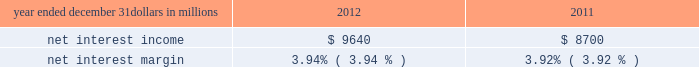Consolidated income statement review our consolidated income statement is presented in item 8 of this report .
Net income for 2012 was $ 3.0 billion compared with $ 3.1 billion for 2011 .
Revenue growth of 8 percent and a decline in the provision for credit losses were more than offset by a 16 percent increase in noninterest expense in 2012 compared to 2011 .
Further detail is included in the net interest income , noninterest income , provision for credit losses and noninterest expense portions of this consolidated income statement review .
Net interest income table 2 : net interest income and net interest margin year ended december 31 dollars in millions 2012 2011 .
Changes in net interest income and margin result from the interaction of the volume and composition of interest-earning assets and related yields , interest-bearing liabilities and related rates paid , and noninterest-bearing sources of funding .
See the statistical information ( unaudited ) 2013 average consolidated balance sheet and net interest analysis and analysis of year-to-year changes in net interest income in item 8 of this report and the discussion of purchase accounting accretion of purchased impaired loans in the consolidated balance sheet review in this item 7 for additional information .
The increase in net interest income in 2012 compared with 2011 was primarily due to the impact of the rbc bank ( usa ) acquisition , organic loan growth and lower funding costs .
Purchase accounting accretion remained stable at $ 1.1 billion in both periods .
The net interest margin was 3.94% ( 3.94 % ) for 2012 and 3.92% ( 3.92 % ) for 2011 .
The increase in the comparison was primarily due to a decrease in the weighted-average rate accrued on total interest- bearing liabilities of 29 basis points , largely offset by a 21 basis point decrease on the yield on total interest-earning assets .
The decrease in the rate on interest-bearing liabilities was primarily due to the runoff of maturing retail certificates of deposit and the redemption of additional trust preferred and hybrid capital securities during 2012 , in addition to an increase in fhlb borrowings and commercial paper as lower-cost funding sources .
The decrease in the yield on interest-earning assets was primarily due to lower rates on new loan volume and lower yields on new securities in the current low rate environment .
With respect to the first quarter of 2013 , we expect net interest income to decline by two to three percent compared to fourth quarter 2012 net interest income of $ 2.4 billion , due to a decrease in purchase accounting accretion of up to $ 50 to $ 60 million , including lower expected cash recoveries .
For the full year 2013 , we expect net interest income to decrease compared with 2012 , assuming an expected decline in purchase accounting accretion of approximately $ 400 million , while core net interest income is expected to increase in the year-over-year comparison .
We believe our net interest margin will come under pressure in 2013 , due to the expected decline in purchase accounting accretion and assuming that the current low rate environment continues .
Noninterest income noninterest income totaled $ 5.9 billion for 2012 and $ 5.6 billion for 2011 .
The overall increase in the comparison was primarily due to an increase in residential mortgage loan sales revenue driven by higher loan origination volume , gains on sales of visa class b common shares and higher corporate service fees , largely offset by higher provision for residential mortgage repurchase obligations .
Asset management revenue , including blackrock , totaled $ 1.2 billion in 2012 compared with $ 1.1 billion in 2011 .
This increase was primarily due to higher earnings from our blackrock investment .
Discretionary assets under management increased to $ 112 billion at december 31 , 2012 compared with $ 107 billion at december 31 , 2011 driven by stronger average equity markets , positive net flows and strong sales performance .
For 2012 , consumer services fees were $ 1.1 billion compared with $ 1.2 billion in 2011 .
The decline reflected the regulatory impact of lower interchange fees on debit card transactions partially offset by customer growth .
As further discussed in the retail banking portion of the business segments review section of this item 7 , the dodd-frank limits on interchange rates were effective october 1 , 2011 and had a negative impact on revenue of approximately $ 314 million in 2012 and $ 75 million in 2011 .
This impact was partially offset by higher volumes of merchant , customer credit card and debit card transactions and the impact of the rbc bank ( usa ) acquisition .
Corporate services revenue increased by $ .3 billion , or 30 percent , to $ 1.2 billion in 2012 compared with $ .9 billion in 2011 due to higher commercial mortgage servicing revenue and higher merger and acquisition advisory fees in 2012 .
The major components of corporate services revenue are treasury management revenue , corporate finance fees , including revenue from capital markets-related products and services , and commercial mortgage servicing revenue , including commercial mortgage banking activities .
See the product revenue portion of this consolidated income statement review for further detail .
The pnc financial services group , inc .
2013 form 10-k 39 .
What was the two year average for net interest income , in millions? 
Computations: ((9640 + 8700) / 2)
Answer: 9170.0. 